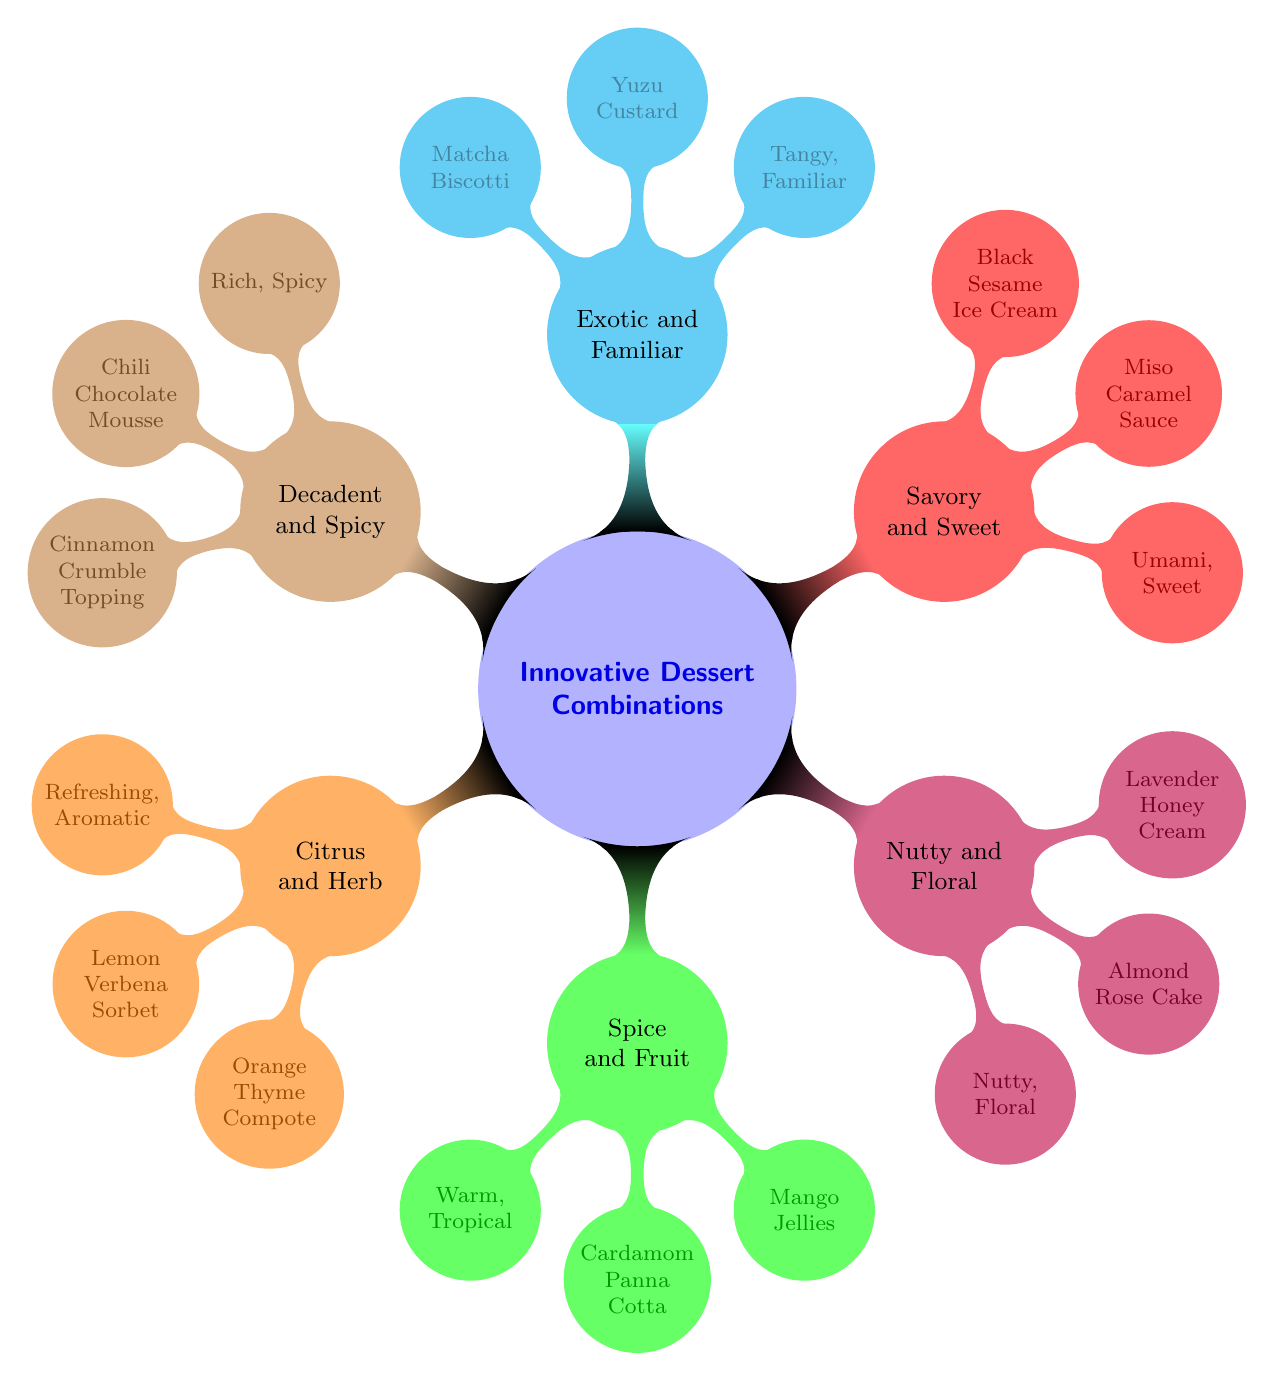What are the ingredients in "Citrus and Herb"? The node "Citrus and Herb" connects to the ingredients list which includes "Lemon Verbena Sorbet" and "Orange Thyme Compote." These two ingredients are directly listed under this category in the diagram.
Answer: Lemon Verbena Sorbet, Orange Thyme Compote What flavor profile is associated with "Savory and Sweet"? The "Savory and Sweet" category has a corresponding flavor profile listed directly beneath it, which describes its taste as "Umami, Sweet." This direct connection makes it easy to identify the associated flavor.
Answer: Umami, Sweet Which dessert is paired with "Decadent and Spicy"? Looking at the "Decadent and Spicy" category, we see that it includes "Chili Chocolate Mousse" as one of its ingredients. This is the specific dessert paired with this flavor combination.
Answer: Chili Chocolate Mousse How many ingredient combinations are listed in total? By counting the distinct categories in the mind map ("Citrus and Herb," "Spice and Fruit," "Nutty and Floral," "Savory and Sweet," "Exotic and Familiar," and "Decadent and Spicy"), we find that there are six different innovative dessert ingredient combinations presented in the diagram.
Answer: 6 What flavor profile combines spices and fruit? The "Spice and Fruit" category is linked to the flavor profile described as "Warm, Tropical." This direct connection indicates what flavor can be expected from the combination of these elements.
Answer: Warm, Tropical Which ingredient is shared between "Nutty and Floral" and "Decadent and Spicy" categories? "Cinnamon Crumble Topping," listed under "Decadent and Spicy," does not appear in "Nutty and Floral" category, indicating there are no shared ingredients between these two categories based on the information in the diagram.
Answer: None What type of ingredients make up the "Exotic and Familiar" category? The "Exotic and Familiar" category contains "Yuzu Custard" and "Matcha Biscotti." These two ingredients are specified directly under this combination, representing what makes up this innovative dessert type.
Answer: Yuzu Custard, Matcha Biscotti 